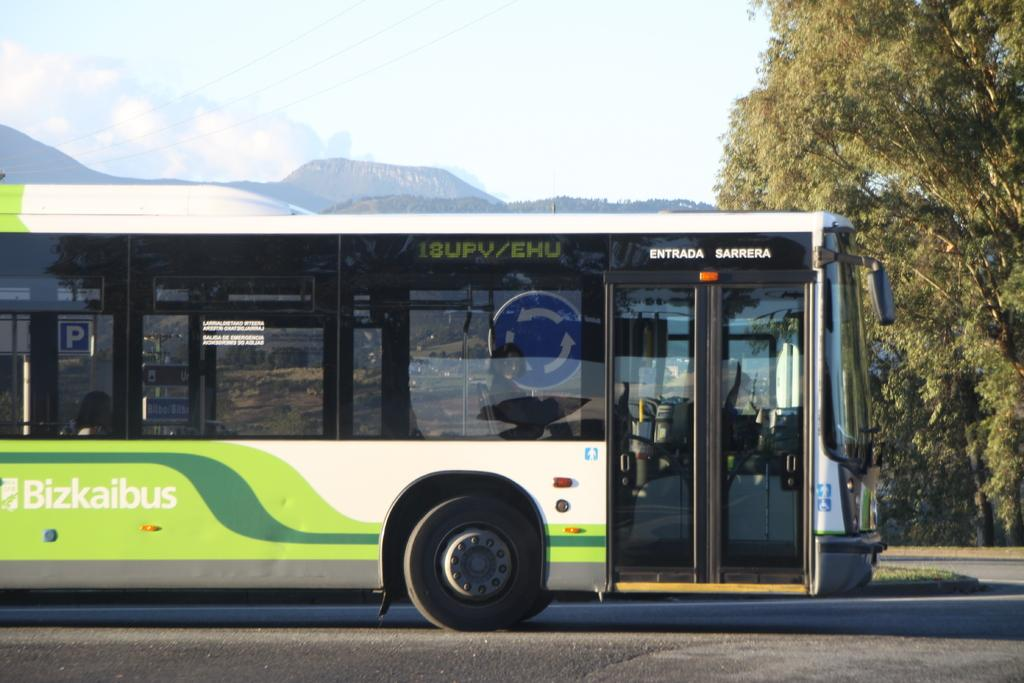<image>
Create a compact narrative representing the image presented. Green and white bus with Entrada near the door. 